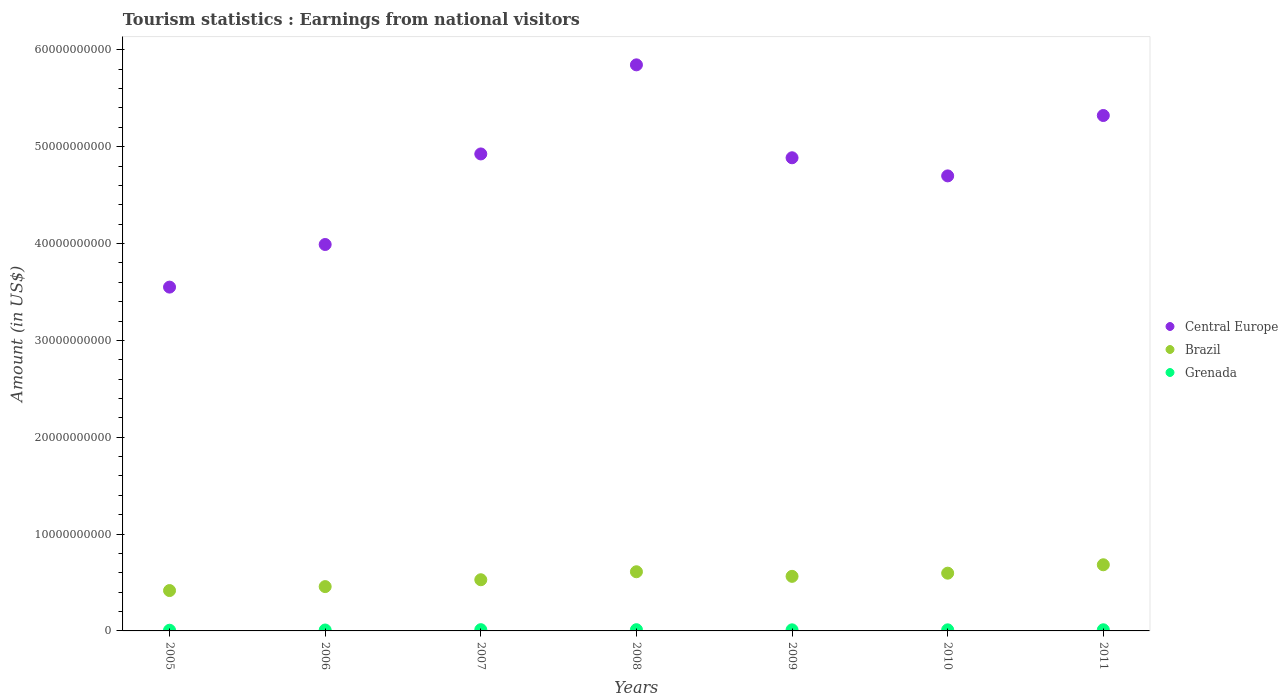How many different coloured dotlines are there?
Your answer should be very brief. 3. Is the number of dotlines equal to the number of legend labels?
Provide a short and direct response. Yes. What is the earnings from national visitors in Grenada in 2007?
Provide a succinct answer. 1.29e+08. Across all years, what is the maximum earnings from national visitors in Central Europe?
Provide a short and direct response. 5.84e+1. Across all years, what is the minimum earnings from national visitors in Grenada?
Offer a very short reply. 7.10e+07. What is the total earnings from national visitors in Central Europe in the graph?
Provide a succinct answer. 3.32e+11. What is the difference between the earnings from national visitors in Grenada in 2009 and that in 2011?
Give a very brief answer. -5.00e+06. What is the difference between the earnings from national visitors in Brazil in 2007 and the earnings from national visitors in Central Europe in 2010?
Offer a terse response. -4.17e+1. What is the average earnings from national visitors in Brazil per year?
Give a very brief answer. 5.51e+09. In the year 2005, what is the difference between the earnings from national visitors in Central Europe and earnings from national visitors in Grenada?
Keep it short and to the point. 3.54e+1. What is the ratio of the earnings from national visitors in Grenada in 2006 to that in 2008?
Your answer should be compact. 0.74. Is the earnings from national visitors in Grenada in 2007 less than that in 2008?
Provide a succinct answer. No. Is the difference between the earnings from national visitors in Central Europe in 2009 and 2011 greater than the difference between the earnings from national visitors in Grenada in 2009 and 2011?
Offer a very short reply. No. What is the difference between the highest and the second highest earnings from national visitors in Brazil?
Keep it short and to the point. 7.21e+08. What is the difference between the highest and the lowest earnings from national visitors in Brazil?
Keep it short and to the point. 2.66e+09. Is it the case that in every year, the sum of the earnings from national visitors in Central Europe and earnings from national visitors in Grenada  is greater than the earnings from national visitors in Brazil?
Offer a terse response. Yes. Is the earnings from national visitors in Central Europe strictly greater than the earnings from national visitors in Brazil over the years?
Provide a short and direct response. Yes. Is the earnings from national visitors in Central Europe strictly less than the earnings from national visitors in Brazil over the years?
Your answer should be compact. No. How many dotlines are there?
Provide a succinct answer. 3. How many years are there in the graph?
Your answer should be compact. 7. What is the difference between two consecutive major ticks on the Y-axis?
Ensure brevity in your answer.  1.00e+1. Are the values on the major ticks of Y-axis written in scientific E-notation?
Make the answer very short. No. Does the graph contain any zero values?
Your response must be concise. No. Where does the legend appear in the graph?
Provide a succinct answer. Center right. How many legend labels are there?
Offer a very short reply. 3. What is the title of the graph?
Give a very brief answer. Tourism statistics : Earnings from national visitors. What is the label or title of the X-axis?
Offer a very short reply. Years. What is the Amount (in US$) in Central Europe in 2005?
Ensure brevity in your answer.  3.55e+1. What is the Amount (in US$) of Brazil in 2005?
Your answer should be compact. 4.17e+09. What is the Amount (in US$) of Grenada in 2005?
Offer a very short reply. 7.10e+07. What is the Amount (in US$) of Central Europe in 2006?
Make the answer very short. 3.99e+1. What is the Amount (in US$) in Brazil in 2006?
Your response must be concise. 4.58e+09. What is the Amount (in US$) in Grenada in 2006?
Ensure brevity in your answer.  9.40e+07. What is the Amount (in US$) of Central Europe in 2007?
Provide a short and direct response. 4.92e+1. What is the Amount (in US$) of Brazil in 2007?
Make the answer very short. 5.28e+09. What is the Amount (in US$) of Grenada in 2007?
Offer a terse response. 1.29e+08. What is the Amount (in US$) in Central Europe in 2008?
Give a very brief answer. 5.84e+1. What is the Amount (in US$) of Brazil in 2008?
Give a very brief answer. 6.11e+09. What is the Amount (in US$) of Grenada in 2008?
Your answer should be compact. 1.27e+08. What is the Amount (in US$) of Central Europe in 2009?
Provide a short and direct response. 4.89e+1. What is the Amount (in US$) in Brazil in 2009?
Keep it short and to the point. 5.64e+09. What is the Amount (in US$) of Grenada in 2009?
Provide a short and direct response. 1.12e+08. What is the Amount (in US$) of Central Europe in 2010?
Make the answer very short. 4.70e+1. What is the Amount (in US$) in Brazil in 2010?
Provide a short and direct response. 5.96e+09. What is the Amount (in US$) of Grenada in 2010?
Give a very brief answer. 1.12e+08. What is the Amount (in US$) of Central Europe in 2011?
Provide a succinct answer. 5.32e+1. What is the Amount (in US$) in Brazil in 2011?
Your response must be concise. 6.83e+09. What is the Amount (in US$) of Grenada in 2011?
Keep it short and to the point. 1.17e+08. Across all years, what is the maximum Amount (in US$) of Central Europe?
Your answer should be compact. 5.84e+1. Across all years, what is the maximum Amount (in US$) in Brazil?
Provide a short and direct response. 6.83e+09. Across all years, what is the maximum Amount (in US$) of Grenada?
Make the answer very short. 1.29e+08. Across all years, what is the minimum Amount (in US$) in Central Europe?
Your answer should be very brief. 3.55e+1. Across all years, what is the minimum Amount (in US$) of Brazil?
Offer a very short reply. 4.17e+09. Across all years, what is the minimum Amount (in US$) of Grenada?
Make the answer very short. 7.10e+07. What is the total Amount (in US$) in Central Europe in the graph?
Your answer should be compact. 3.32e+11. What is the total Amount (in US$) in Brazil in the graph?
Keep it short and to the point. 3.86e+1. What is the total Amount (in US$) in Grenada in the graph?
Ensure brevity in your answer.  7.62e+08. What is the difference between the Amount (in US$) of Central Europe in 2005 and that in 2006?
Make the answer very short. -4.40e+09. What is the difference between the Amount (in US$) of Brazil in 2005 and that in 2006?
Your answer should be very brief. -4.09e+08. What is the difference between the Amount (in US$) in Grenada in 2005 and that in 2006?
Provide a succinct answer. -2.30e+07. What is the difference between the Amount (in US$) of Central Europe in 2005 and that in 2007?
Your response must be concise. -1.38e+1. What is the difference between the Amount (in US$) in Brazil in 2005 and that in 2007?
Keep it short and to the point. -1.12e+09. What is the difference between the Amount (in US$) in Grenada in 2005 and that in 2007?
Offer a terse response. -5.80e+07. What is the difference between the Amount (in US$) in Central Europe in 2005 and that in 2008?
Offer a terse response. -2.30e+1. What is the difference between the Amount (in US$) of Brazil in 2005 and that in 2008?
Provide a succinct answer. -1.94e+09. What is the difference between the Amount (in US$) of Grenada in 2005 and that in 2008?
Offer a very short reply. -5.60e+07. What is the difference between the Amount (in US$) of Central Europe in 2005 and that in 2009?
Give a very brief answer. -1.34e+1. What is the difference between the Amount (in US$) in Brazil in 2005 and that in 2009?
Offer a very short reply. -1.47e+09. What is the difference between the Amount (in US$) in Grenada in 2005 and that in 2009?
Provide a succinct answer. -4.10e+07. What is the difference between the Amount (in US$) of Central Europe in 2005 and that in 2010?
Your response must be concise. -1.15e+1. What is the difference between the Amount (in US$) of Brazil in 2005 and that in 2010?
Your response must be concise. -1.80e+09. What is the difference between the Amount (in US$) of Grenada in 2005 and that in 2010?
Your answer should be very brief. -4.10e+07. What is the difference between the Amount (in US$) in Central Europe in 2005 and that in 2011?
Offer a terse response. -1.77e+1. What is the difference between the Amount (in US$) of Brazil in 2005 and that in 2011?
Your answer should be compact. -2.66e+09. What is the difference between the Amount (in US$) of Grenada in 2005 and that in 2011?
Your answer should be very brief. -4.60e+07. What is the difference between the Amount (in US$) in Central Europe in 2006 and that in 2007?
Provide a short and direct response. -9.35e+09. What is the difference between the Amount (in US$) in Brazil in 2006 and that in 2007?
Provide a succinct answer. -7.07e+08. What is the difference between the Amount (in US$) in Grenada in 2006 and that in 2007?
Offer a terse response. -3.50e+07. What is the difference between the Amount (in US$) in Central Europe in 2006 and that in 2008?
Make the answer very short. -1.86e+1. What is the difference between the Amount (in US$) of Brazil in 2006 and that in 2008?
Your answer should be compact. -1.53e+09. What is the difference between the Amount (in US$) in Grenada in 2006 and that in 2008?
Your answer should be compact. -3.30e+07. What is the difference between the Amount (in US$) of Central Europe in 2006 and that in 2009?
Make the answer very short. -8.96e+09. What is the difference between the Amount (in US$) of Brazil in 2006 and that in 2009?
Make the answer very short. -1.06e+09. What is the difference between the Amount (in US$) of Grenada in 2006 and that in 2009?
Your answer should be very brief. -1.80e+07. What is the difference between the Amount (in US$) of Central Europe in 2006 and that in 2010?
Your answer should be very brief. -7.08e+09. What is the difference between the Amount (in US$) of Brazil in 2006 and that in 2010?
Provide a short and direct response. -1.39e+09. What is the difference between the Amount (in US$) in Grenada in 2006 and that in 2010?
Give a very brief answer. -1.80e+07. What is the difference between the Amount (in US$) of Central Europe in 2006 and that in 2011?
Keep it short and to the point. -1.33e+1. What is the difference between the Amount (in US$) in Brazil in 2006 and that in 2011?
Offer a very short reply. -2.25e+09. What is the difference between the Amount (in US$) of Grenada in 2006 and that in 2011?
Offer a terse response. -2.30e+07. What is the difference between the Amount (in US$) of Central Europe in 2007 and that in 2008?
Provide a short and direct response. -9.20e+09. What is the difference between the Amount (in US$) of Brazil in 2007 and that in 2008?
Your answer should be compact. -8.25e+08. What is the difference between the Amount (in US$) of Central Europe in 2007 and that in 2009?
Ensure brevity in your answer.  3.95e+08. What is the difference between the Amount (in US$) of Brazil in 2007 and that in 2009?
Offer a very short reply. -3.51e+08. What is the difference between the Amount (in US$) of Grenada in 2007 and that in 2009?
Provide a succinct answer. 1.70e+07. What is the difference between the Amount (in US$) in Central Europe in 2007 and that in 2010?
Offer a very short reply. 2.27e+09. What is the difference between the Amount (in US$) of Brazil in 2007 and that in 2010?
Offer a terse response. -6.79e+08. What is the difference between the Amount (in US$) of Grenada in 2007 and that in 2010?
Your answer should be compact. 1.70e+07. What is the difference between the Amount (in US$) in Central Europe in 2007 and that in 2011?
Ensure brevity in your answer.  -3.97e+09. What is the difference between the Amount (in US$) of Brazil in 2007 and that in 2011?
Keep it short and to the point. -1.55e+09. What is the difference between the Amount (in US$) in Central Europe in 2008 and that in 2009?
Make the answer very short. 9.60e+09. What is the difference between the Amount (in US$) of Brazil in 2008 and that in 2009?
Make the answer very short. 4.74e+08. What is the difference between the Amount (in US$) in Grenada in 2008 and that in 2009?
Offer a very short reply. 1.50e+07. What is the difference between the Amount (in US$) in Central Europe in 2008 and that in 2010?
Your response must be concise. 1.15e+1. What is the difference between the Amount (in US$) of Brazil in 2008 and that in 2010?
Offer a very short reply. 1.46e+08. What is the difference between the Amount (in US$) of Grenada in 2008 and that in 2010?
Offer a very short reply. 1.50e+07. What is the difference between the Amount (in US$) of Central Europe in 2008 and that in 2011?
Provide a succinct answer. 5.23e+09. What is the difference between the Amount (in US$) in Brazil in 2008 and that in 2011?
Your answer should be very brief. -7.21e+08. What is the difference between the Amount (in US$) of Grenada in 2008 and that in 2011?
Give a very brief answer. 1.00e+07. What is the difference between the Amount (in US$) of Central Europe in 2009 and that in 2010?
Your answer should be compact. 1.87e+09. What is the difference between the Amount (in US$) in Brazil in 2009 and that in 2010?
Ensure brevity in your answer.  -3.28e+08. What is the difference between the Amount (in US$) of Central Europe in 2009 and that in 2011?
Give a very brief answer. -4.36e+09. What is the difference between the Amount (in US$) in Brazil in 2009 and that in 2011?
Provide a short and direct response. -1.20e+09. What is the difference between the Amount (in US$) of Grenada in 2009 and that in 2011?
Provide a short and direct response. -5.00e+06. What is the difference between the Amount (in US$) in Central Europe in 2010 and that in 2011?
Offer a terse response. -6.24e+09. What is the difference between the Amount (in US$) of Brazil in 2010 and that in 2011?
Your response must be concise. -8.67e+08. What is the difference between the Amount (in US$) of Grenada in 2010 and that in 2011?
Provide a short and direct response. -5.00e+06. What is the difference between the Amount (in US$) of Central Europe in 2005 and the Amount (in US$) of Brazil in 2006?
Offer a very short reply. 3.09e+1. What is the difference between the Amount (in US$) of Central Europe in 2005 and the Amount (in US$) of Grenada in 2006?
Provide a succinct answer. 3.54e+1. What is the difference between the Amount (in US$) of Brazil in 2005 and the Amount (in US$) of Grenada in 2006?
Your response must be concise. 4.07e+09. What is the difference between the Amount (in US$) in Central Europe in 2005 and the Amount (in US$) in Brazil in 2007?
Give a very brief answer. 3.02e+1. What is the difference between the Amount (in US$) of Central Europe in 2005 and the Amount (in US$) of Grenada in 2007?
Offer a terse response. 3.54e+1. What is the difference between the Amount (in US$) in Brazil in 2005 and the Amount (in US$) in Grenada in 2007?
Give a very brief answer. 4.04e+09. What is the difference between the Amount (in US$) of Central Europe in 2005 and the Amount (in US$) of Brazil in 2008?
Provide a succinct answer. 2.94e+1. What is the difference between the Amount (in US$) of Central Europe in 2005 and the Amount (in US$) of Grenada in 2008?
Offer a very short reply. 3.54e+1. What is the difference between the Amount (in US$) in Brazil in 2005 and the Amount (in US$) in Grenada in 2008?
Offer a terse response. 4.04e+09. What is the difference between the Amount (in US$) in Central Europe in 2005 and the Amount (in US$) in Brazil in 2009?
Your answer should be very brief. 2.99e+1. What is the difference between the Amount (in US$) in Central Europe in 2005 and the Amount (in US$) in Grenada in 2009?
Your answer should be compact. 3.54e+1. What is the difference between the Amount (in US$) in Brazil in 2005 and the Amount (in US$) in Grenada in 2009?
Ensure brevity in your answer.  4.06e+09. What is the difference between the Amount (in US$) in Central Europe in 2005 and the Amount (in US$) in Brazil in 2010?
Give a very brief answer. 2.95e+1. What is the difference between the Amount (in US$) of Central Europe in 2005 and the Amount (in US$) of Grenada in 2010?
Offer a terse response. 3.54e+1. What is the difference between the Amount (in US$) in Brazil in 2005 and the Amount (in US$) in Grenada in 2010?
Provide a short and direct response. 4.06e+09. What is the difference between the Amount (in US$) of Central Europe in 2005 and the Amount (in US$) of Brazil in 2011?
Give a very brief answer. 2.87e+1. What is the difference between the Amount (in US$) in Central Europe in 2005 and the Amount (in US$) in Grenada in 2011?
Ensure brevity in your answer.  3.54e+1. What is the difference between the Amount (in US$) in Brazil in 2005 and the Amount (in US$) in Grenada in 2011?
Give a very brief answer. 4.05e+09. What is the difference between the Amount (in US$) in Central Europe in 2006 and the Amount (in US$) in Brazil in 2007?
Offer a very short reply. 3.46e+1. What is the difference between the Amount (in US$) of Central Europe in 2006 and the Amount (in US$) of Grenada in 2007?
Offer a terse response. 3.98e+1. What is the difference between the Amount (in US$) in Brazil in 2006 and the Amount (in US$) in Grenada in 2007?
Provide a succinct answer. 4.45e+09. What is the difference between the Amount (in US$) in Central Europe in 2006 and the Amount (in US$) in Brazil in 2008?
Your answer should be very brief. 3.38e+1. What is the difference between the Amount (in US$) of Central Europe in 2006 and the Amount (in US$) of Grenada in 2008?
Your answer should be compact. 3.98e+1. What is the difference between the Amount (in US$) of Brazil in 2006 and the Amount (in US$) of Grenada in 2008?
Keep it short and to the point. 4.45e+09. What is the difference between the Amount (in US$) of Central Europe in 2006 and the Amount (in US$) of Brazil in 2009?
Ensure brevity in your answer.  3.43e+1. What is the difference between the Amount (in US$) of Central Europe in 2006 and the Amount (in US$) of Grenada in 2009?
Ensure brevity in your answer.  3.98e+1. What is the difference between the Amount (in US$) in Brazil in 2006 and the Amount (in US$) in Grenada in 2009?
Keep it short and to the point. 4.46e+09. What is the difference between the Amount (in US$) of Central Europe in 2006 and the Amount (in US$) of Brazil in 2010?
Offer a terse response. 3.39e+1. What is the difference between the Amount (in US$) in Central Europe in 2006 and the Amount (in US$) in Grenada in 2010?
Give a very brief answer. 3.98e+1. What is the difference between the Amount (in US$) in Brazil in 2006 and the Amount (in US$) in Grenada in 2010?
Ensure brevity in your answer.  4.46e+09. What is the difference between the Amount (in US$) in Central Europe in 2006 and the Amount (in US$) in Brazil in 2011?
Provide a short and direct response. 3.31e+1. What is the difference between the Amount (in US$) of Central Europe in 2006 and the Amount (in US$) of Grenada in 2011?
Your answer should be compact. 3.98e+1. What is the difference between the Amount (in US$) of Brazil in 2006 and the Amount (in US$) of Grenada in 2011?
Give a very brief answer. 4.46e+09. What is the difference between the Amount (in US$) of Central Europe in 2007 and the Amount (in US$) of Brazil in 2008?
Ensure brevity in your answer.  4.31e+1. What is the difference between the Amount (in US$) of Central Europe in 2007 and the Amount (in US$) of Grenada in 2008?
Your answer should be very brief. 4.91e+1. What is the difference between the Amount (in US$) in Brazil in 2007 and the Amount (in US$) in Grenada in 2008?
Offer a very short reply. 5.16e+09. What is the difference between the Amount (in US$) of Central Europe in 2007 and the Amount (in US$) of Brazil in 2009?
Your answer should be very brief. 4.36e+1. What is the difference between the Amount (in US$) in Central Europe in 2007 and the Amount (in US$) in Grenada in 2009?
Give a very brief answer. 4.91e+1. What is the difference between the Amount (in US$) of Brazil in 2007 and the Amount (in US$) of Grenada in 2009?
Your answer should be compact. 5.17e+09. What is the difference between the Amount (in US$) of Central Europe in 2007 and the Amount (in US$) of Brazil in 2010?
Ensure brevity in your answer.  4.33e+1. What is the difference between the Amount (in US$) in Central Europe in 2007 and the Amount (in US$) in Grenada in 2010?
Offer a very short reply. 4.91e+1. What is the difference between the Amount (in US$) in Brazil in 2007 and the Amount (in US$) in Grenada in 2010?
Offer a very short reply. 5.17e+09. What is the difference between the Amount (in US$) of Central Europe in 2007 and the Amount (in US$) of Brazil in 2011?
Ensure brevity in your answer.  4.24e+1. What is the difference between the Amount (in US$) in Central Europe in 2007 and the Amount (in US$) in Grenada in 2011?
Your response must be concise. 4.91e+1. What is the difference between the Amount (in US$) of Brazil in 2007 and the Amount (in US$) of Grenada in 2011?
Offer a terse response. 5.17e+09. What is the difference between the Amount (in US$) of Central Europe in 2008 and the Amount (in US$) of Brazil in 2009?
Ensure brevity in your answer.  5.28e+1. What is the difference between the Amount (in US$) of Central Europe in 2008 and the Amount (in US$) of Grenada in 2009?
Make the answer very short. 5.83e+1. What is the difference between the Amount (in US$) in Brazil in 2008 and the Amount (in US$) in Grenada in 2009?
Your answer should be very brief. 6.00e+09. What is the difference between the Amount (in US$) in Central Europe in 2008 and the Amount (in US$) in Brazil in 2010?
Provide a succinct answer. 5.25e+1. What is the difference between the Amount (in US$) in Central Europe in 2008 and the Amount (in US$) in Grenada in 2010?
Make the answer very short. 5.83e+1. What is the difference between the Amount (in US$) of Brazil in 2008 and the Amount (in US$) of Grenada in 2010?
Keep it short and to the point. 6.00e+09. What is the difference between the Amount (in US$) in Central Europe in 2008 and the Amount (in US$) in Brazil in 2011?
Offer a very short reply. 5.16e+1. What is the difference between the Amount (in US$) of Central Europe in 2008 and the Amount (in US$) of Grenada in 2011?
Make the answer very short. 5.83e+1. What is the difference between the Amount (in US$) of Brazil in 2008 and the Amount (in US$) of Grenada in 2011?
Your answer should be very brief. 5.99e+09. What is the difference between the Amount (in US$) of Central Europe in 2009 and the Amount (in US$) of Brazil in 2010?
Keep it short and to the point. 4.29e+1. What is the difference between the Amount (in US$) in Central Europe in 2009 and the Amount (in US$) in Grenada in 2010?
Your response must be concise. 4.87e+1. What is the difference between the Amount (in US$) of Brazil in 2009 and the Amount (in US$) of Grenada in 2010?
Give a very brief answer. 5.52e+09. What is the difference between the Amount (in US$) in Central Europe in 2009 and the Amount (in US$) in Brazil in 2011?
Your answer should be compact. 4.20e+1. What is the difference between the Amount (in US$) of Central Europe in 2009 and the Amount (in US$) of Grenada in 2011?
Your answer should be very brief. 4.87e+1. What is the difference between the Amount (in US$) of Brazil in 2009 and the Amount (in US$) of Grenada in 2011?
Your response must be concise. 5.52e+09. What is the difference between the Amount (in US$) in Central Europe in 2010 and the Amount (in US$) in Brazil in 2011?
Your answer should be compact. 4.02e+1. What is the difference between the Amount (in US$) in Central Europe in 2010 and the Amount (in US$) in Grenada in 2011?
Make the answer very short. 4.69e+1. What is the difference between the Amount (in US$) of Brazil in 2010 and the Amount (in US$) of Grenada in 2011?
Offer a very short reply. 5.85e+09. What is the average Amount (in US$) in Central Europe per year?
Offer a very short reply. 4.75e+1. What is the average Amount (in US$) of Brazil per year?
Give a very brief answer. 5.51e+09. What is the average Amount (in US$) in Grenada per year?
Offer a terse response. 1.09e+08. In the year 2005, what is the difference between the Amount (in US$) of Central Europe and Amount (in US$) of Brazil?
Make the answer very short. 3.13e+1. In the year 2005, what is the difference between the Amount (in US$) of Central Europe and Amount (in US$) of Grenada?
Your response must be concise. 3.54e+1. In the year 2005, what is the difference between the Amount (in US$) in Brazil and Amount (in US$) in Grenada?
Your answer should be compact. 4.10e+09. In the year 2006, what is the difference between the Amount (in US$) of Central Europe and Amount (in US$) of Brazil?
Provide a short and direct response. 3.53e+1. In the year 2006, what is the difference between the Amount (in US$) in Central Europe and Amount (in US$) in Grenada?
Offer a terse response. 3.98e+1. In the year 2006, what is the difference between the Amount (in US$) of Brazil and Amount (in US$) of Grenada?
Your answer should be very brief. 4.48e+09. In the year 2007, what is the difference between the Amount (in US$) of Central Europe and Amount (in US$) of Brazil?
Your response must be concise. 4.40e+1. In the year 2007, what is the difference between the Amount (in US$) of Central Europe and Amount (in US$) of Grenada?
Offer a very short reply. 4.91e+1. In the year 2007, what is the difference between the Amount (in US$) in Brazil and Amount (in US$) in Grenada?
Provide a short and direct response. 5.16e+09. In the year 2008, what is the difference between the Amount (in US$) in Central Europe and Amount (in US$) in Brazil?
Provide a short and direct response. 5.23e+1. In the year 2008, what is the difference between the Amount (in US$) of Central Europe and Amount (in US$) of Grenada?
Make the answer very short. 5.83e+1. In the year 2008, what is the difference between the Amount (in US$) of Brazil and Amount (in US$) of Grenada?
Your answer should be very brief. 5.98e+09. In the year 2009, what is the difference between the Amount (in US$) of Central Europe and Amount (in US$) of Brazil?
Your answer should be very brief. 4.32e+1. In the year 2009, what is the difference between the Amount (in US$) of Central Europe and Amount (in US$) of Grenada?
Keep it short and to the point. 4.87e+1. In the year 2009, what is the difference between the Amount (in US$) in Brazil and Amount (in US$) in Grenada?
Your answer should be very brief. 5.52e+09. In the year 2010, what is the difference between the Amount (in US$) of Central Europe and Amount (in US$) of Brazil?
Offer a very short reply. 4.10e+1. In the year 2010, what is the difference between the Amount (in US$) in Central Europe and Amount (in US$) in Grenada?
Give a very brief answer. 4.69e+1. In the year 2010, what is the difference between the Amount (in US$) in Brazil and Amount (in US$) in Grenada?
Offer a terse response. 5.85e+09. In the year 2011, what is the difference between the Amount (in US$) of Central Europe and Amount (in US$) of Brazil?
Ensure brevity in your answer.  4.64e+1. In the year 2011, what is the difference between the Amount (in US$) in Central Europe and Amount (in US$) in Grenada?
Your response must be concise. 5.31e+1. In the year 2011, what is the difference between the Amount (in US$) in Brazil and Amount (in US$) in Grenada?
Give a very brief answer. 6.71e+09. What is the ratio of the Amount (in US$) of Central Europe in 2005 to that in 2006?
Provide a short and direct response. 0.89. What is the ratio of the Amount (in US$) of Brazil in 2005 to that in 2006?
Offer a very short reply. 0.91. What is the ratio of the Amount (in US$) in Grenada in 2005 to that in 2006?
Offer a very short reply. 0.76. What is the ratio of the Amount (in US$) of Central Europe in 2005 to that in 2007?
Provide a succinct answer. 0.72. What is the ratio of the Amount (in US$) of Brazil in 2005 to that in 2007?
Keep it short and to the point. 0.79. What is the ratio of the Amount (in US$) in Grenada in 2005 to that in 2007?
Your answer should be very brief. 0.55. What is the ratio of the Amount (in US$) in Central Europe in 2005 to that in 2008?
Your answer should be compact. 0.61. What is the ratio of the Amount (in US$) of Brazil in 2005 to that in 2008?
Your answer should be compact. 0.68. What is the ratio of the Amount (in US$) of Grenada in 2005 to that in 2008?
Keep it short and to the point. 0.56. What is the ratio of the Amount (in US$) of Central Europe in 2005 to that in 2009?
Keep it short and to the point. 0.73. What is the ratio of the Amount (in US$) in Brazil in 2005 to that in 2009?
Provide a succinct answer. 0.74. What is the ratio of the Amount (in US$) in Grenada in 2005 to that in 2009?
Ensure brevity in your answer.  0.63. What is the ratio of the Amount (in US$) in Central Europe in 2005 to that in 2010?
Provide a short and direct response. 0.76. What is the ratio of the Amount (in US$) of Brazil in 2005 to that in 2010?
Make the answer very short. 0.7. What is the ratio of the Amount (in US$) of Grenada in 2005 to that in 2010?
Ensure brevity in your answer.  0.63. What is the ratio of the Amount (in US$) in Central Europe in 2005 to that in 2011?
Your answer should be very brief. 0.67. What is the ratio of the Amount (in US$) of Brazil in 2005 to that in 2011?
Your answer should be compact. 0.61. What is the ratio of the Amount (in US$) in Grenada in 2005 to that in 2011?
Your answer should be very brief. 0.61. What is the ratio of the Amount (in US$) in Central Europe in 2006 to that in 2007?
Provide a short and direct response. 0.81. What is the ratio of the Amount (in US$) in Brazil in 2006 to that in 2007?
Keep it short and to the point. 0.87. What is the ratio of the Amount (in US$) of Grenada in 2006 to that in 2007?
Make the answer very short. 0.73. What is the ratio of the Amount (in US$) of Central Europe in 2006 to that in 2008?
Provide a succinct answer. 0.68. What is the ratio of the Amount (in US$) in Brazil in 2006 to that in 2008?
Make the answer very short. 0.75. What is the ratio of the Amount (in US$) of Grenada in 2006 to that in 2008?
Your response must be concise. 0.74. What is the ratio of the Amount (in US$) of Central Europe in 2006 to that in 2009?
Make the answer very short. 0.82. What is the ratio of the Amount (in US$) of Brazil in 2006 to that in 2009?
Provide a short and direct response. 0.81. What is the ratio of the Amount (in US$) of Grenada in 2006 to that in 2009?
Provide a succinct answer. 0.84. What is the ratio of the Amount (in US$) of Central Europe in 2006 to that in 2010?
Your answer should be compact. 0.85. What is the ratio of the Amount (in US$) in Brazil in 2006 to that in 2010?
Ensure brevity in your answer.  0.77. What is the ratio of the Amount (in US$) in Grenada in 2006 to that in 2010?
Provide a short and direct response. 0.84. What is the ratio of the Amount (in US$) in Central Europe in 2006 to that in 2011?
Offer a terse response. 0.75. What is the ratio of the Amount (in US$) of Brazil in 2006 to that in 2011?
Provide a succinct answer. 0.67. What is the ratio of the Amount (in US$) of Grenada in 2006 to that in 2011?
Your response must be concise. 0.8. What is the ratio of the Amount (in US$) of Central Europe in 2007 to that in 2008?
Your answer should be compact. 0.84. What is the ratio of the Amount (in US$) in Brazil in 2007 to that in 2008?
Offer a terse response. 0.86. What is the ratio of the Amount (in US$) of Grenada in 2007 to that in 2008?
Your answer should be compact. 1.02. What is the ratio of the Amount (in US$) in Central Europe in 2007 to that in 2009?
Provide a short and direct response. 1.01. What is the ratio of the Amount (in US$) in Brazil in 2007 to that in 2009?
Offer a very short reply. 0.94. What is the ratio of the Amount (in US$) in Grenada in 2007 to that in 2009?
Provide a succinct answer. 1.15. What is the ratio of the Amount (in US$) of Central Europe in 2007 to that in 2010?
Make the answer very short. 1.05. What is the ratio of the Amount (in US$) in Brazil in 2007 to that in 2010?
Offer a terse response. 0.89. What is the ratio of the Amount (in US$) of Grenada in 2007 to that in 2010?
Offer a very short reply. 1.15. What is the ratio of the Amount (in US$) in Central Europe in 2007 to that in 2011?
Your answer should be compact. 0.93. What is the ratio of the Amount (in US$) of Brazil in 2007 to that in 2011?
Keep it short and to the point. 0.77. What is the ratio of the Amount (in US$) in Grenada in 2007 to that in 2011?
Provide a short and direct response. 1.1. What is the ratio of the Amount (in US$) in Central Europe in 2008 to that in 2009?
Offer a very short reply. 1.2. What is the ratio of the Amount (in US$) in Brazil in 2008 to that in 2009?
Make the answer very short. 1.08. What is the ratio of the Amount (in US$) in Grenada in 2008 to that in 2009?
Your answer should be very brief. 1.13. What is the ratio of the Amount (in US$) of Central Europe in 2008 to that in 2010?
Your answer should be compact. 1.24. What is the ratio of the Amount (in US$) in Brazil in 2008 to that in 2010?
Give a very brief answer. 1.02. What is the ratio of the Amount (in US$) of Grenada in 2008 to that in 2010?
Offer a very short reply. 1.13. What is the ratio of the Amount (in US$) of Central Europe in 2008 to that in 2011?
Offer a very short reply. 1.1. What is the ratio of the Amount (in US$) of Brazil in 2008 to that in 2011?
Your answer should be very brief. 0.89. What is the ratio of the Amount (in US$) of Grenada in 2008 to that in 2011?
Your answer should be very brief. 1.09. What is the ratio of the Amount (in US$) in Central Europe in 2009 to that in 2010?
Ensure brevity in your answer.  1.04. What is the ratio of the Amount (in US$) of Brazil in 2009 to that in 2010?
Give a very brief answer. 0.94. What is the ratio of the Amount (in US$) in Grenada in 2009 to that in 2010?
Provide a succinct answer. 1. What is the ratio of the Amount (in US$) in Central Europe in 2009 to that in 2011?
Offer a very short reply. 0.92. What is the ratio of the Amount (in US$) in Brazil in 2009 to that in 2011?
Provide a succinct answer. 0.82. What is the ratio of the Amount (in US$) of Grenada in 2009 to that in 2011?
Provide a short and direct response. 0.96. What is the ratio of the Amount (in US$) of Central Europe in 2010 to that in 2011?
Provide a succinct answer. 0.88. What is the ratio of the Amount (in US$) in Brazil in 2010 to that in 2011?
Ensure brevity in your answer.  0.87. What is the ratio of the Amount (in US$) of Grenada in 2010 to that in 2011?
Provide a succinct answer. 0.96. What is the difference between the highest and the second highest Amount (in US$) of Central Europe?
Provide a short and direct response. 5.23e+09. What is the difference between the highest and the second highest Amount (in US$) in Brazil?
Your response must be concise. 7.21e+08. What is the difference between the highest and the lowest Amount (in US$) in Central Europe?
Your answer should be compact. 2.30e+1. What is the difference between the highest and the lowest Amount (in US$) in Brazil?
Your answer should be compact. 2.66e+09. What is the difference between the highest and the lowest Amount (in US$) in Grenada?
Give a very brief answer. 5.80e+07. 